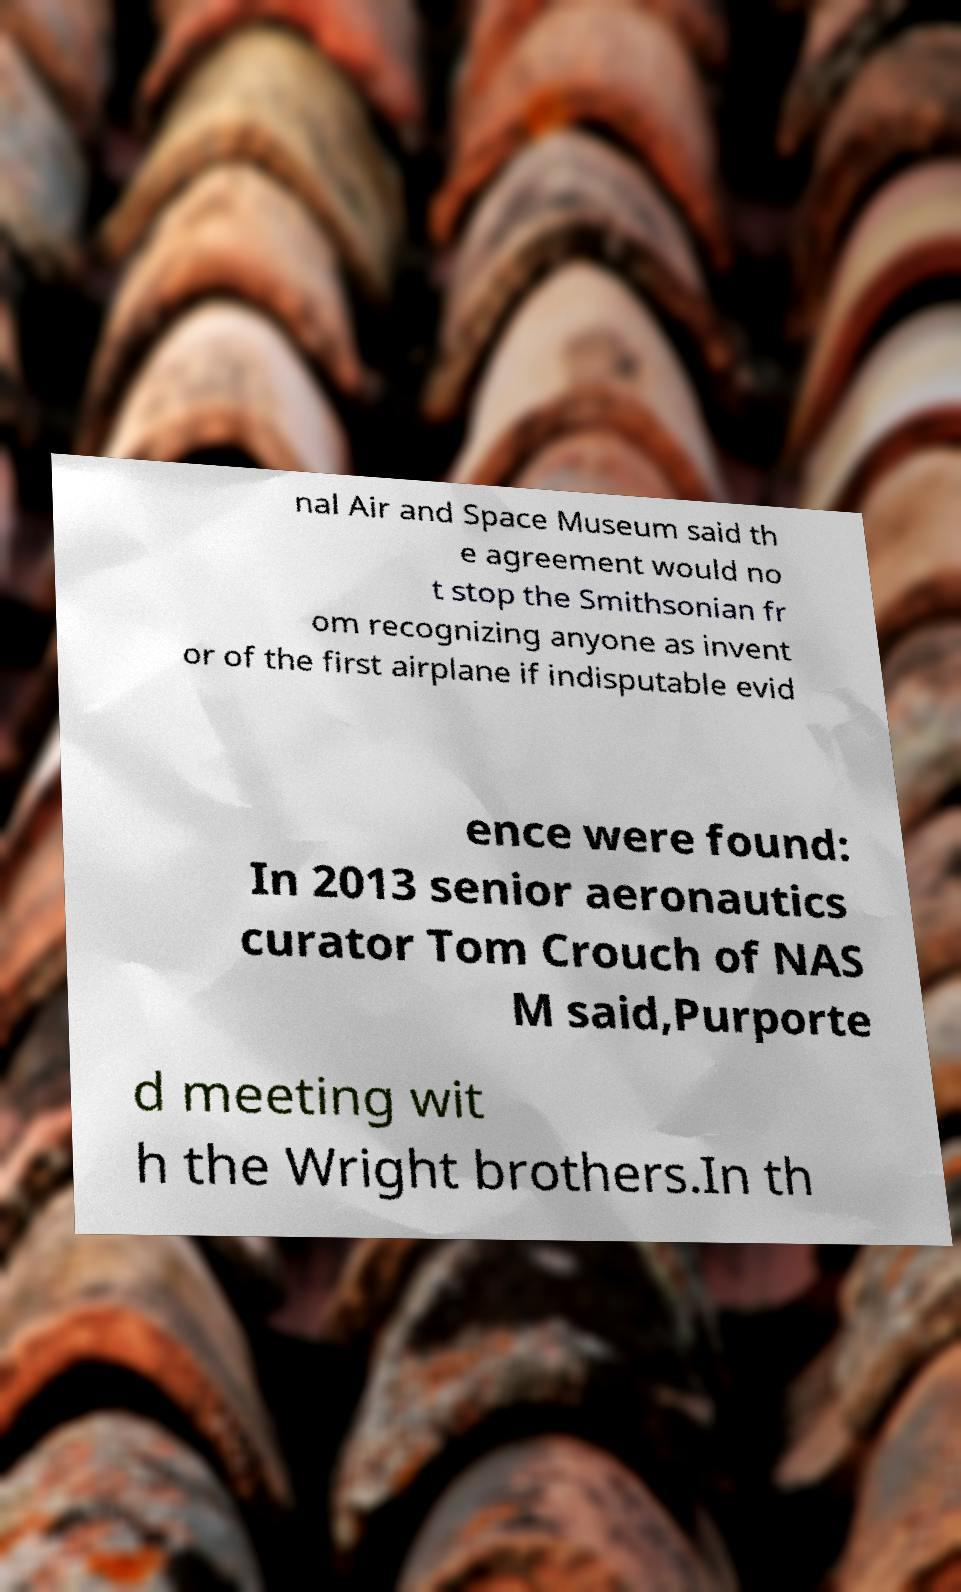Could you extract and type out the text from this image? nal Air and Space Museum said th e agreement would no t stop the Smithsonian fr om recognizing anyone as invent or of the first airplane if indisputable evid ence were found: In 2013 senior aeronautics curator Tom Crouch of NAS M said,Purporte d meeting wit h the Wright brothers.In th 